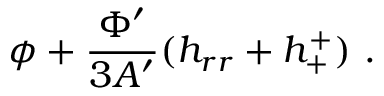Convert formula to latex. <formula><loc_0><loc_0><loc_500><loc_500>\phi + \frac { \Phi ^ { \prime } } { 3 A ^ { \prime } } ( h _ { r r } + h _ { + } ^ { + } ) .</formula> 